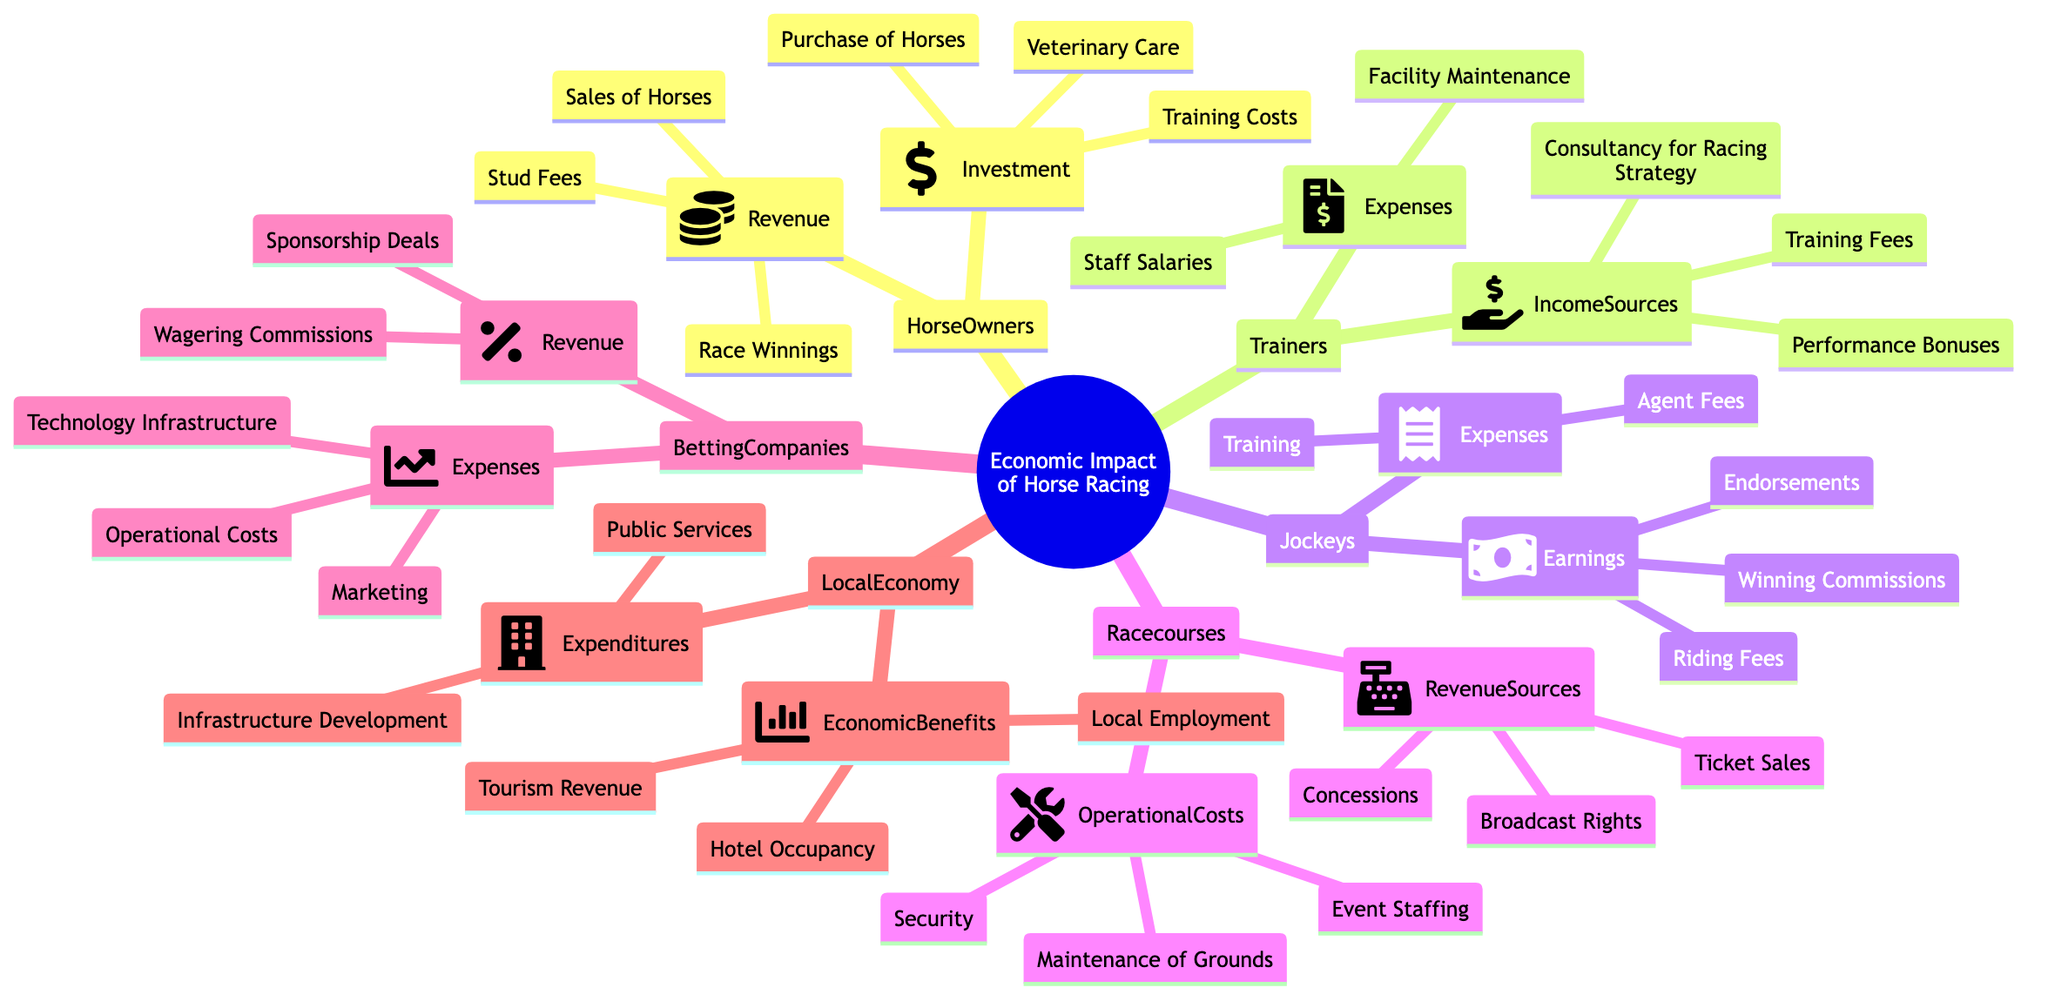What are the main revenue sources for racecourses? The diagram shows the revenue sources for racecourses as Ticket Sales, Broadcast Rights, and Concessions. By identifying the node labeled "RevenueSources" under the "Racecourses" section, I can list these three sources directly.
Answer: Ticket Sales, Broadcast Rights, Concessions How many different stakeholders are involved in horse racing? The diagram identifies different stakeholders, which include Horse Owners, Trainers, Jockeys, Racecourses, Betting Companies, and Local Economy. Counting these distinct nodes provides the total.
Answer: 6 What is a major way trainers earn income? The diagram indicates that trainers earn income primarily through Training Fees, Performance Bonuses, and Consultancy for Racing Strategy. Selecting the "IncomeSources" node under "Trainers" provides these options.
Answer: Training Fees How do betting companies primarily generate revenue? The information in the diagram specifies that betting companies generate revenue from Wagering Commissions and Sponsorship Deals. These are found in the "Revenue" node for "BettingCompanies."
Answer: Wagering Commissions, Sponsorship Deals What economic benefit does horse racing bring to the local economy? The diagram highlights that one of the economic benefits to the local economy from horse racing is Tourism Revenue. This is listed under the "EconomicBenefits" node for "LocalEconomy."
Answer: Tourism Revenue What is a common expense for jockeys? The expenses of jockeys include Training and Agent Fees. By examining the "Expenses" node under "Jockeys," these are the two identified expenses.
Answer: Training, Agent Fees Which stakeholder has expenses related to facility maintenance? The diagram shows that trainers incur expenses for Facility Maintenance among other costs. This is specifically mentioned under the "Expenses" section of the "Trainers" stakeholder.
Answer: Trainers What are the operational costs for racecourses? The operational costs for racecourses include Maintenance of Grounds, Event Staffing, and Security. This information is listed under the "OperationalCosts" node of "Racecourses."
Answer: Maintenance of Grounds, Event Staffing, Security Which stakeholders are involved in training costs? The diagram indicates that training costs are associated with Horse Owners, as this is included in their "Investment" section. Thus, the primary stakeholder for training costs is defined.
Answer: Horse Owners 